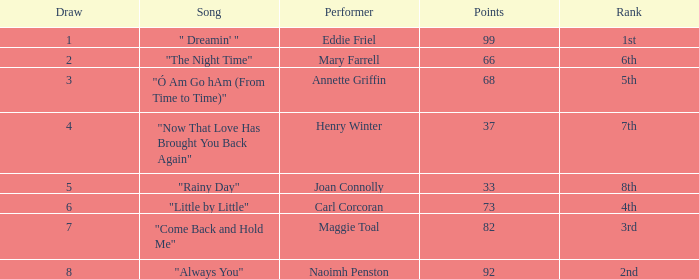What is the lowest points when the ranking is 1st? 99.0. 